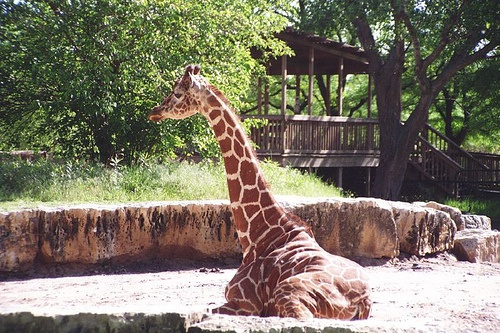Describe the objects in this image and their specific colors. I can see a giraffe in darkgray, maroon, white, brown, and lightpink tones in this image. 